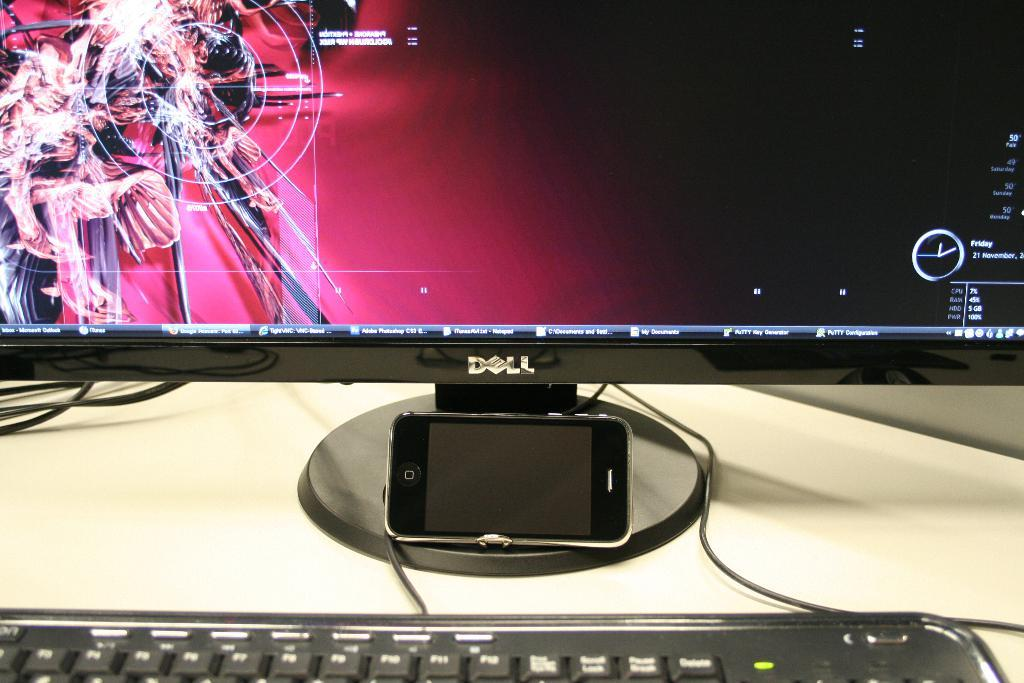<image>
Share a concise interpretation of the image provided. A Dell monitor that shows that Adobe Photoshop is open on it. 